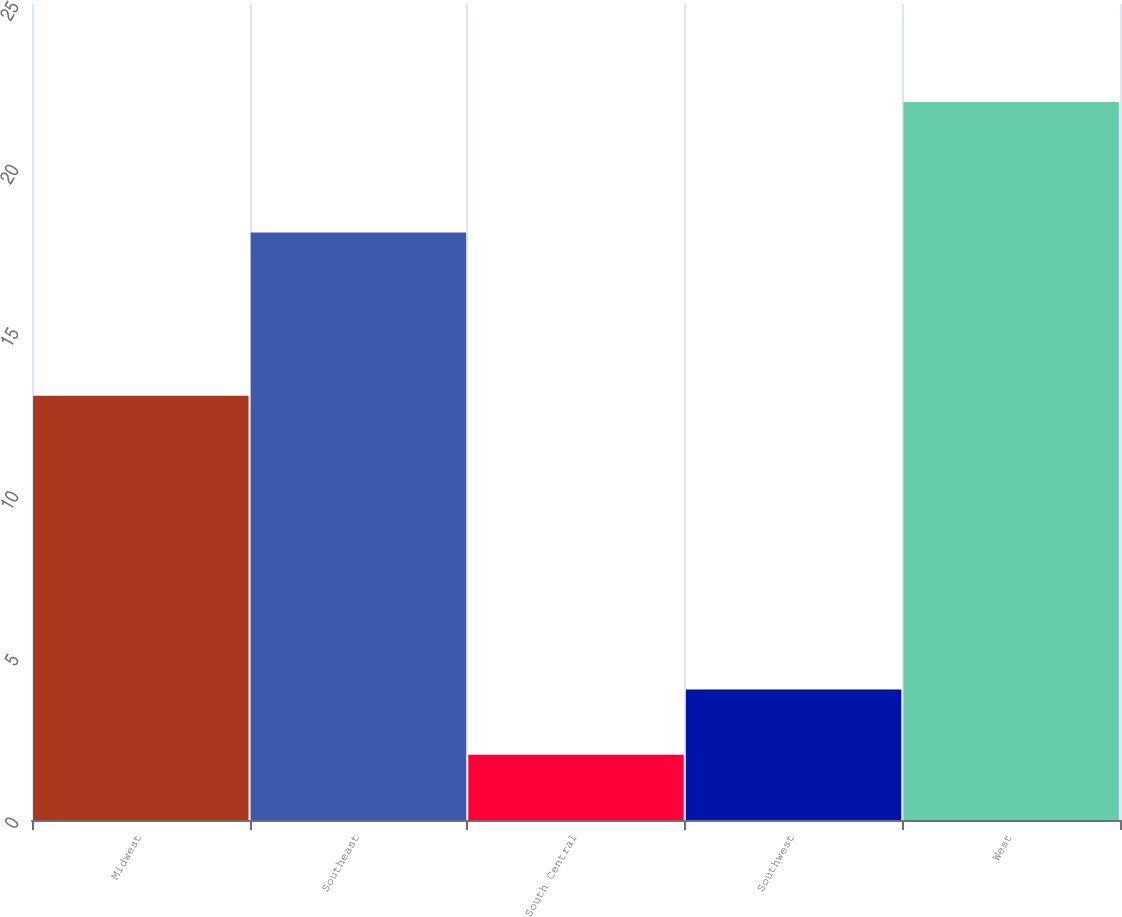Convert chart to OTSL. <chart><loc_0><loc_0><loc_500><loc_500><bar_chart><fcel>Midwest<fcel>Southeast<fcel>South Central<fcel>Southwest<fcel>West<nl><fcel>13<fcel>18<fcel>2<fcel>4<fcel>22<nl></chart> 